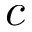<formula> <loc_0><loc_0><loc_500><loc_500>c</formula> 